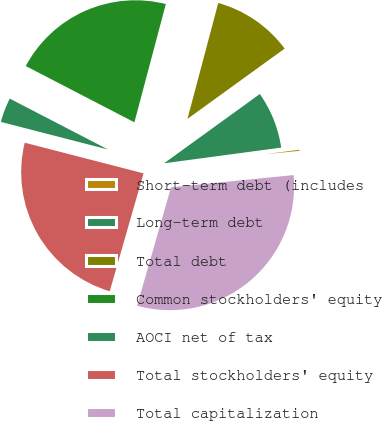Convert chart to OTSL. <chart><loc_0><loc_0><loc_500><loc_500><pie_chart><fcel>Short-term debt (includes<fcel>Long-term debt<fcel>Total debt<fcel>Common stockholders' equity<fcel>AOCI net of tax<fcel>Total stockholders' equity<fcel>Total capitalization<nl><fcel>0.54%<fcel>7.85%<fcel>10.9%<fcel>21.53%<fcel>3.59%<fcel>24.58%<fcel>31.03%<nl></chart> 